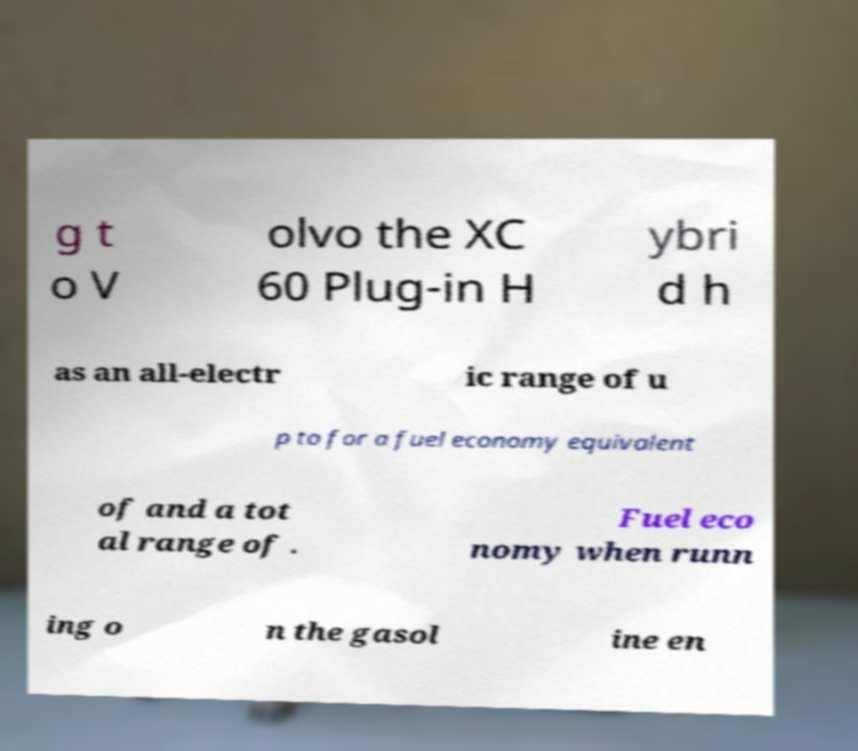I need the written content from this picture converted into text. Can you do that? g t o V olvo the XC 60 Plug-in H ybri d h as an all-electr ic range of u p to for a fuel economy equivalent of and a tot al range of . Fuel eco nomy when runn ing o n the gasol ine en 